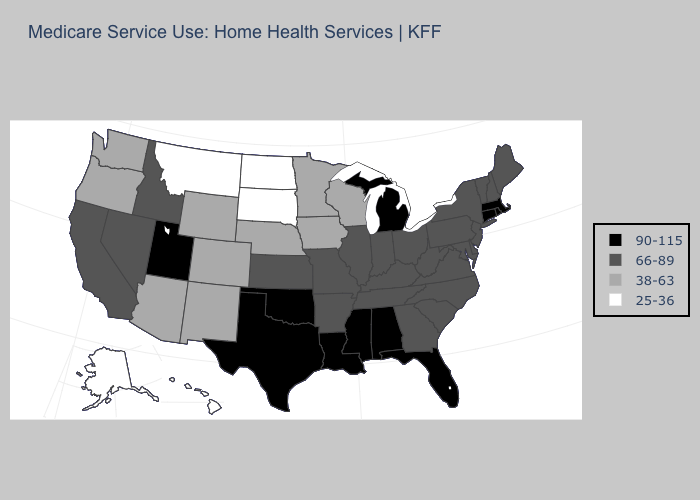What is the lowest value in the USA?
Concise answer only. 25-36. Which states have the lowest value in the USA?
Concise answer only. Alaska, Hawaii, Montana, North Dakota, South Dakota. What is the value of Missouri?
Answer briefly. 66-89. Does New York have the highest value in the USA?
Answer briefly. No. Among the states that border Utah , which have the lowest value?
Short answer required. Arizona, Colorado, New Mexico, Wyoming. Name the states that have a value in the range 38-63?
Quick response, please. Arizona, Colorado, Iowa, Minnesota, Nebraska, New Mexico, Oregon, Washington, Wisconsin, Wyoming. Does Louisiana have the highest value in the USA?
Quick response, please. Yes. What is the value of Idaho?
Give a very brief answer. 66-89. What is the highest value in the MidWest ?
Give a very brief answer. 90-115. Name the states that have a value in the range 25-36?
Short answer required. Alaska, Hawaii, Montana, North Dakota, South Dakota. Among the states that border Arkansas , which have the highest value?
Quick response, please. Louisiana, Mississippi, Oklahoma, Texas. Does North Carolina have the highest value in the South?
Answer briefly. No. Name the states that have a value in the range 66-89?
Short answer required. Arkansas, California, Delaware, Georgia, Idaho, Illinois, Indiana, Kansas, Kentucky, Maine, Maryland, Missouri, Nevada, New Hampshire, New Jersey, New York, North Carolina, Ohio, Pennsylvania, South Carolina, Tennessee, Vermont, Virginia, West Virginia. Does the map have missing data?
Give a very brief answer. No. 